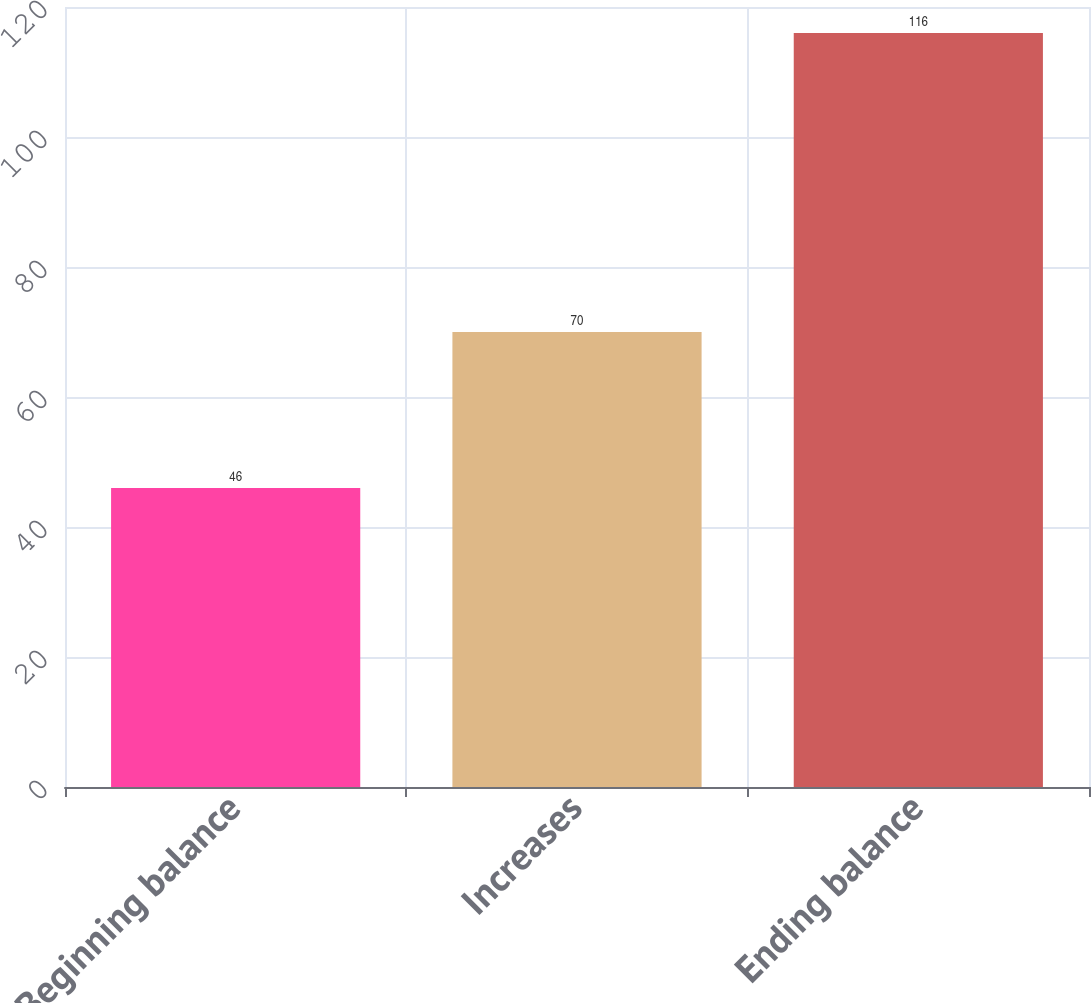Convert chart. <chart><loc_0><loc_0><loc_500><loc_500><bar_chart><fcel>Beginning balance<fcel>Increases<fcel>Ending balance<nl><fcel>46<fcel>70<fcel>116<nl></chart> 